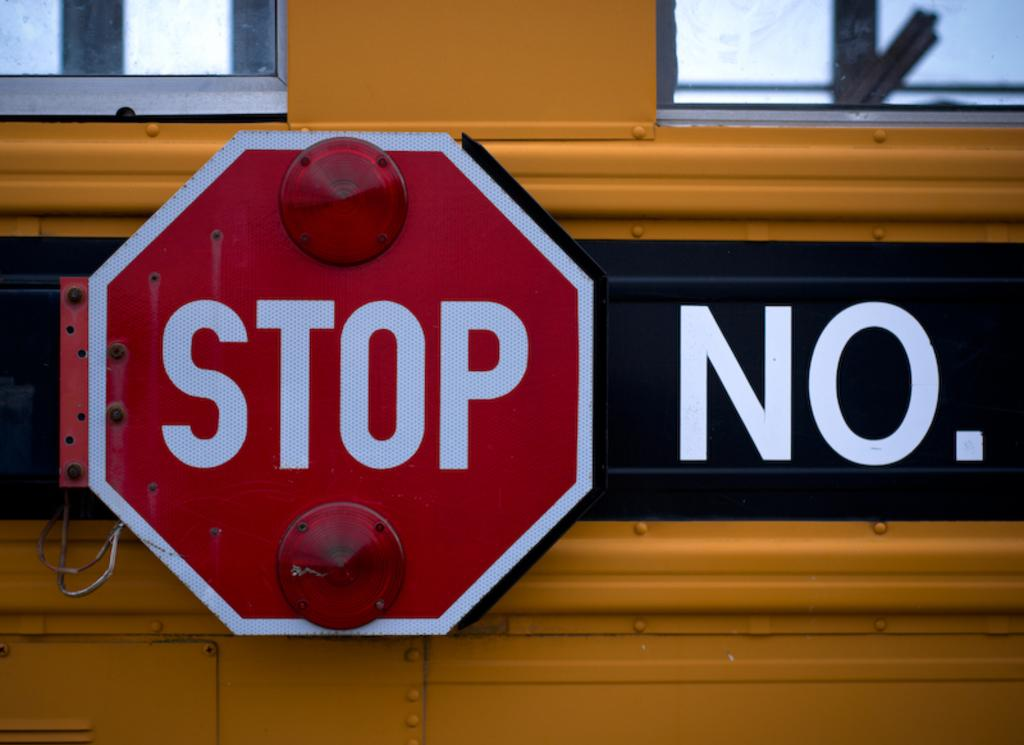<image>
Share a concise interpretation of the image provided. A bright red STOP sign is to the left of the letters, "NO." on a yellow bus. 